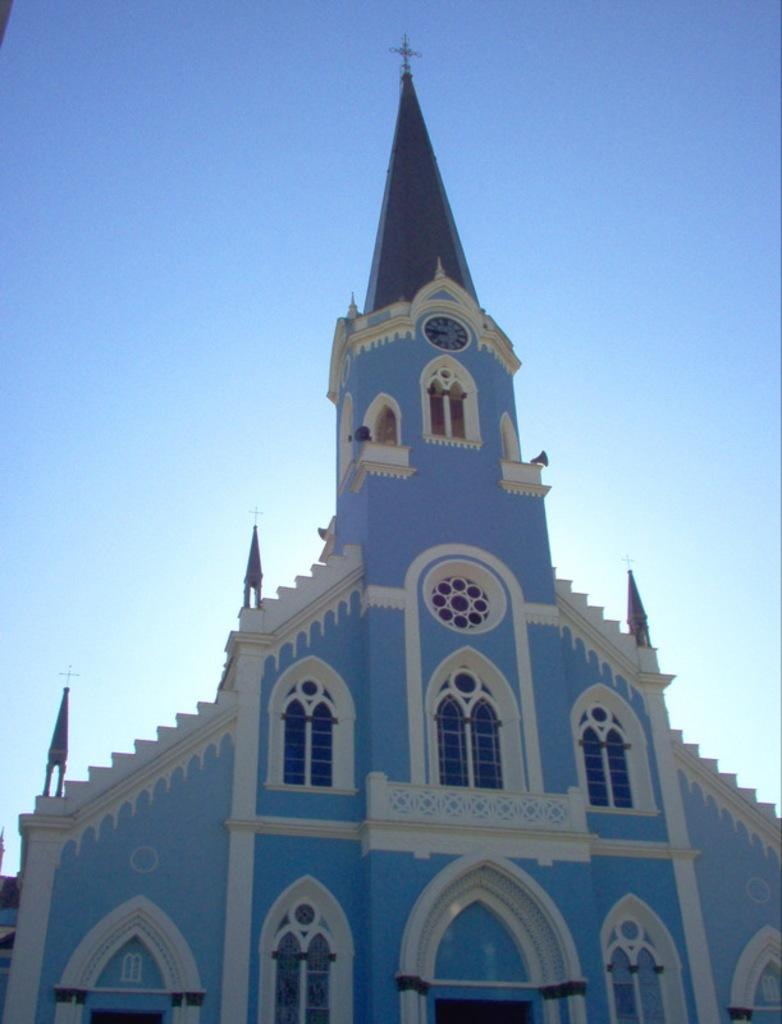What structure is the main subject of the image? There is a building in the image. What feature can be seen on the building? There is a clock on the building. Are there any symbols or decorations on the building? Yes, there are holly cross symbols on the building. What can be seen in the background of the image? The sky is visible behind the building. How many rabbits can be seen playing with a bone in the image? There are no rabbits or bones present in the image; it features a building with a clock and holly cross symbols. 